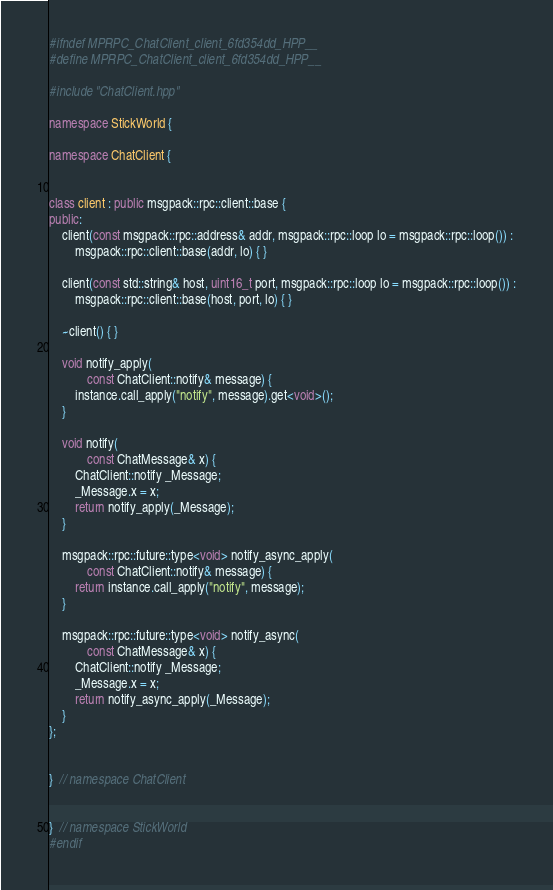Convert code to text. <code><loc_0><loc_0><loc_500><loc_500><_C++_>#ifndef MPRPC_ChatClient_client_6fd354dd_HPP__
#define MPRPC_ChatClient_client_6fd354dd_HPP__

#include "ChatClient.hpp"

namespace StickWorld {

namespace ChatClient {


class client : public msgpack::rpc::client::base {
public:
	client(const msgpack::rpc::address& addr, msgpack::rpc::loop lo = msgpack::rpc::loop()) :
		msgpack::rpc::client::base(addr, lo) { }

	client(const std::string& host, uint16_t port, msgpack::rpc::loop lo = msgpack::rpc::loop()) :
		msgpack::rpc::client::base(host, port, lo) { }

	~client() { }

	void notify_apply(
			const ChatClient::notify& message) {
		instance.call_apply("notify", message).get<void>();
	}

	void notify(
			const ChatMessage& x) {
		ChatClient::notify _Message;
		_Message.x = x;
		return notify_apply(_Message);
	}

	msgpack::rpc::future::type<void> notify_async_apply(
			const ChatClient::notify& message) {
		return instance.call_apply("notify", message);
	}

	msgpack::rpc::future::type<void> notify_async(
			const ChatMessage& x) {
		ChatClient::notify _Message;
		_Message.x = x;
		return notify_async_apply(_Message);
	}
};


}  // namespace ChatClient


}  // namespace StickWorld
#endif
</code> 